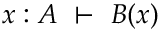Convert formula to latex. <formula><loc_0><loc_0><loc_500><loc_500>x \colon A \ \vdash \ B ( x )</formula> 